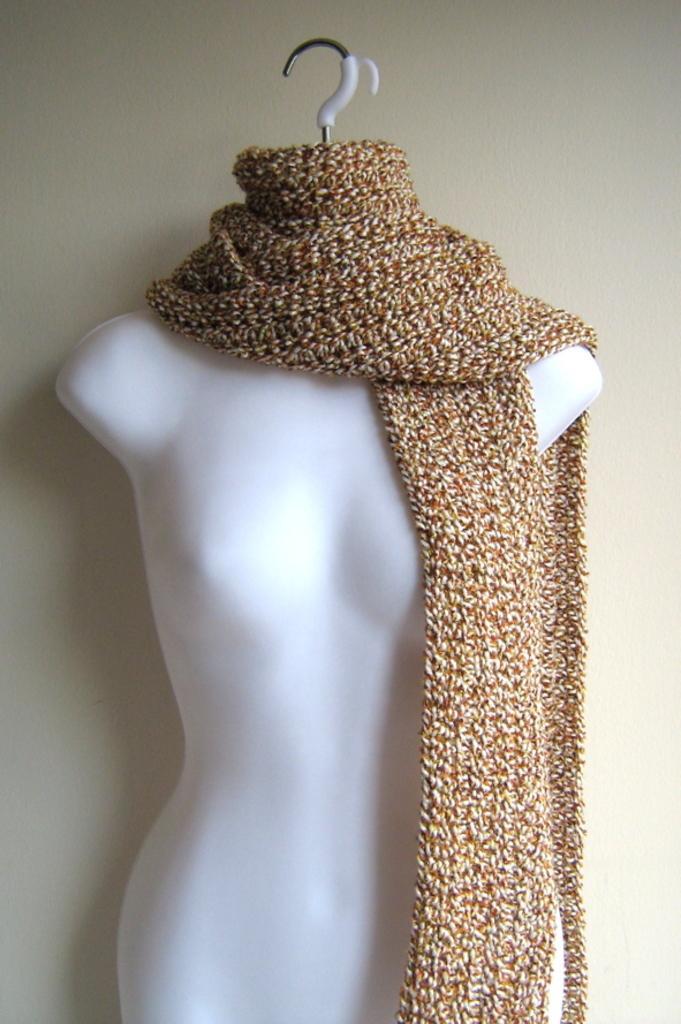In one or two sentences, can you explain what this image depicts? In the picture I can see a mannequin which has a cloth placed on it. 